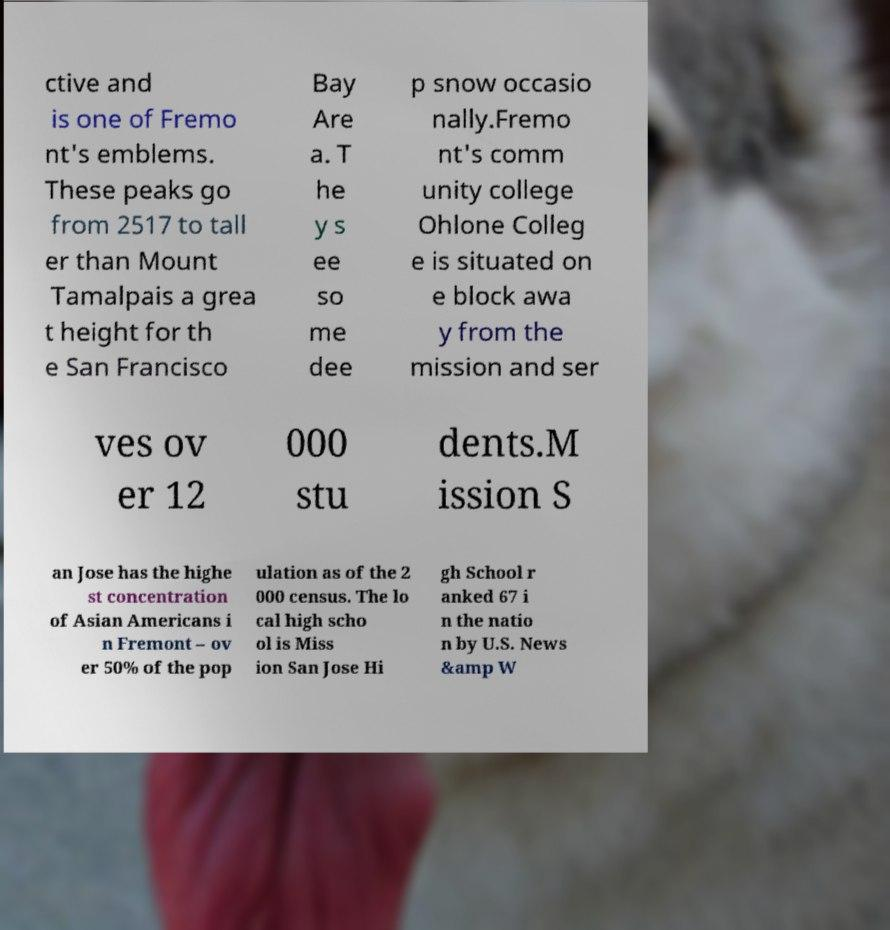I need the written content from this picture converted into text. Can you do that? ctive and is one of Fremo nt's emblems. These peaks go from 2517 to tall er than Mount Tamalpais a grea t height for th e San Francisco Bay Are a. T he y s ee so me dee p snow occasio nally.Fremo nt's comm unity college Ohlone Colleg e is situated on e block awa y from the mission and ser ves ov er 12 000 stu dents.M ission S an Jose has the highe st concentration of Asian Americans i n Fremont – ov er 50% of the pop ulation as of the 2 000 census. The lo cal high scho ol is Miss ion San Jose Hi gh School r anked 67 i n the natio n by U.S. News &amp W 